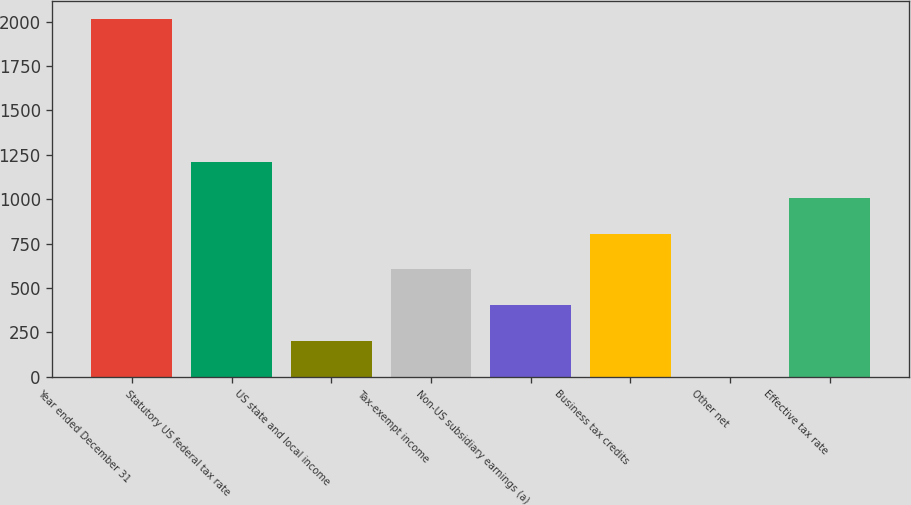<chart> <loc_0><loc_0><loc_500><loc_500><bar_chart><fcel>Year ended December 31<fcel>Statutory US federal tax rate<fcel>US state and local income<fcel>Tax-exempt income<fcel>Non-US subsidiary earnings (a)<fcel>Business tax credits<fcel>Other net<fcel>Effective tax rate<nl><fcel>2017<fcel>1210.24<fcel>201.79<fcel>605.17<fcel>403.48<fcel>806.86<fcel>0.1<fcel>1008.55<nl></chart> 